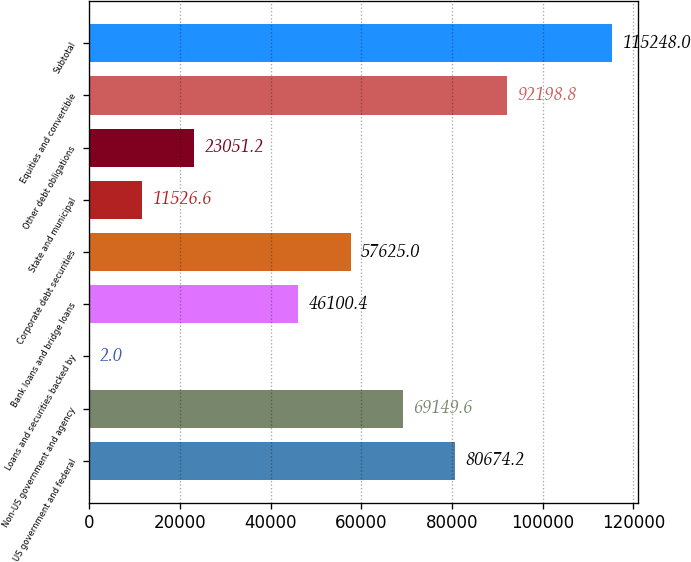Convert chart. <chart><loc_0><loc_0><loc_500><loc_500><bar_chart><fcel>US government and federal<fcel>Non-US government and agency<fcel>Loans and securities backed by<fcel>Bank loans and bridge loans<fcel>Corporate debt securities<fcel>State and municipal<fcel>Other debt obligations<fcel>Equities and convertible<fcel>Subtotal<nl><fcel>80674.2<fcel>69149.6<fcel>2<fcel>46100.4<fcel>57625<fcel>11526.6<fcel>23051.2<fcel>92198.8<fcel>115248<nl></chart> 